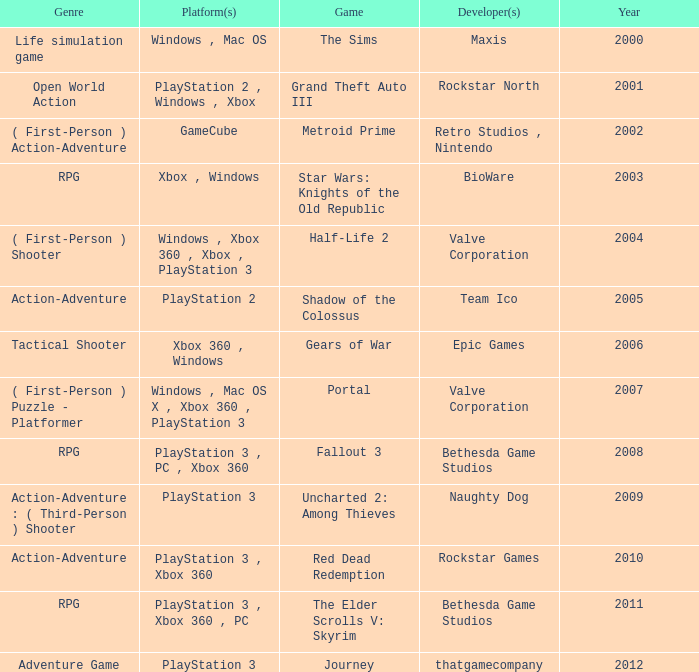What's the genre of The Sims before 2002? Life simulation game. 